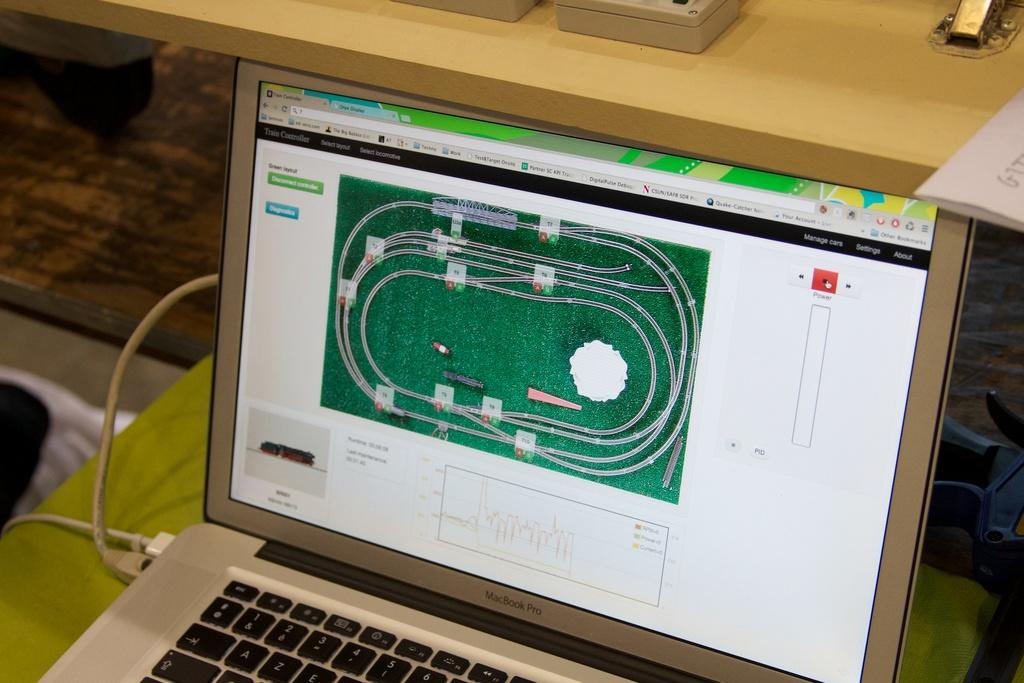Provide a one-sentence caption for the provided image. A Macbook Pro laptap with an image of a miniature railroad. 